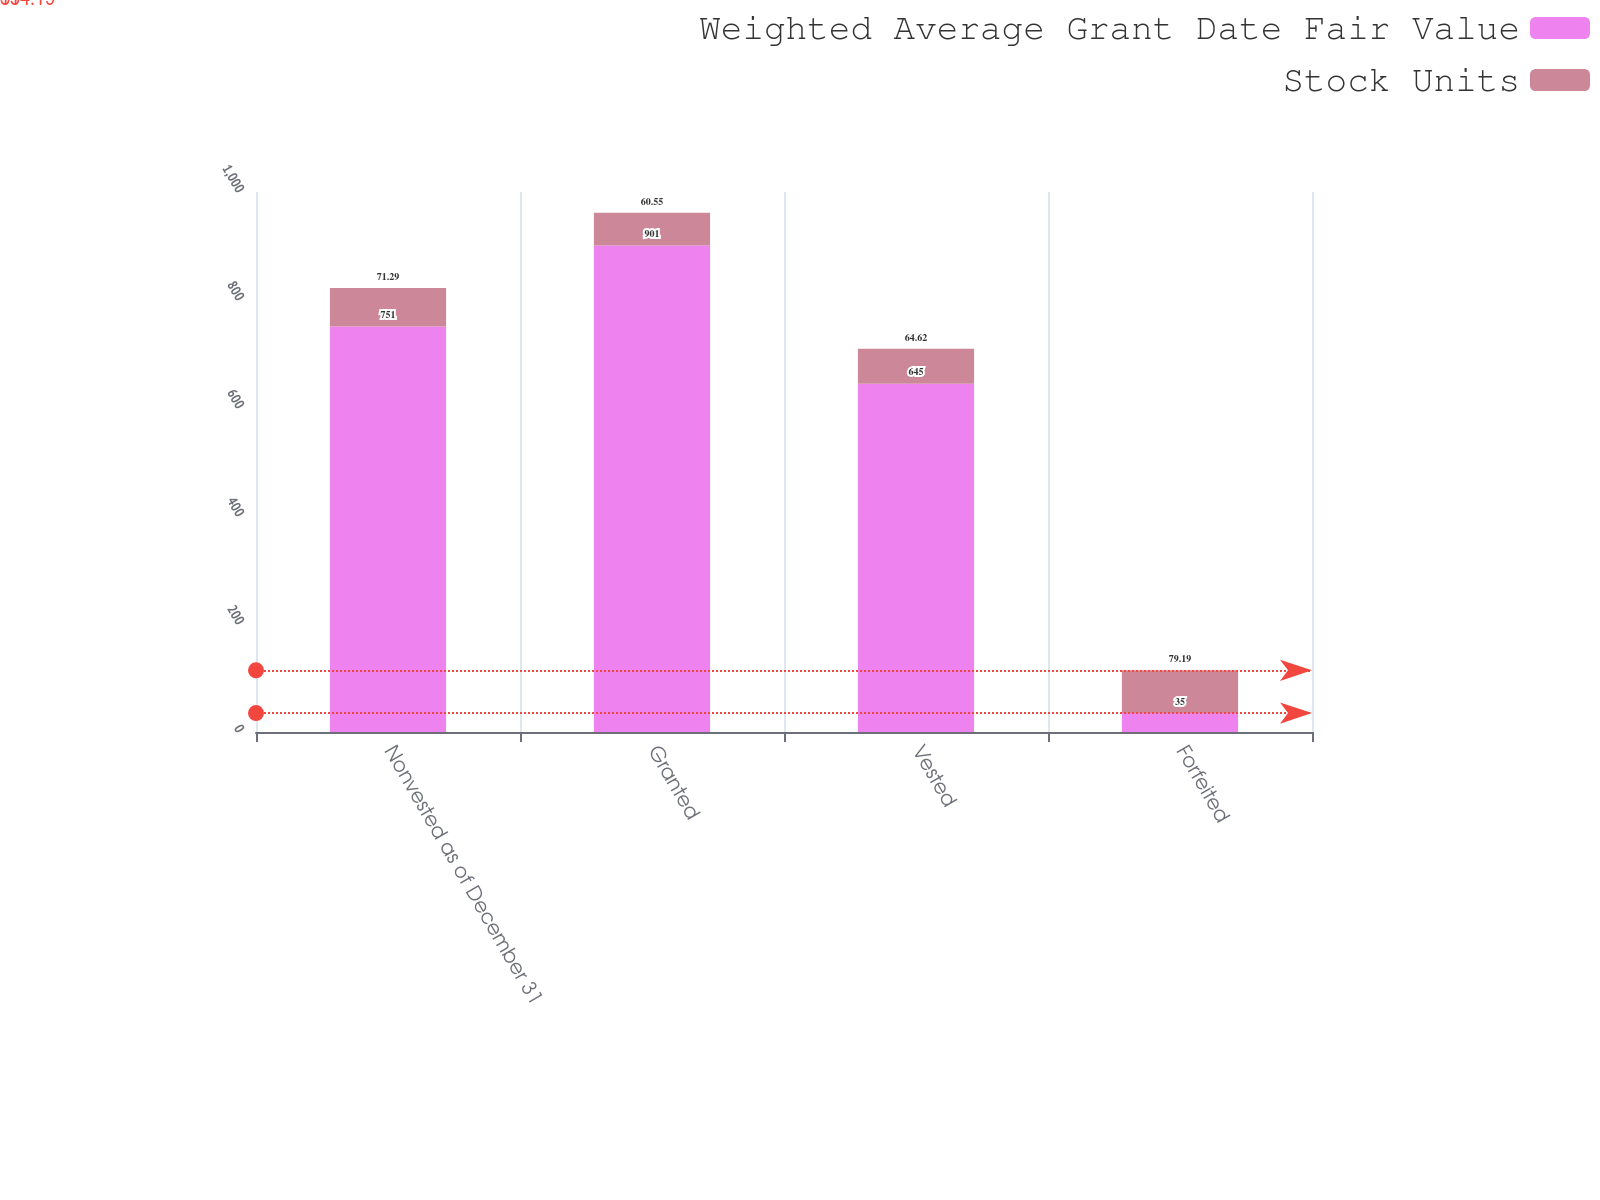Convert chart to OTSL. <chart><loc_0><loc_0><loc_500><loc_500><stacked_bar_chart><ecel><fcel>Nonvested as of December 31<fcel>Granted<fcel>Vested<fcel>Forfeited<nl><fcel>Weighted Average Grant Date Fair Value<fcel>751<fcel>901<fcel>645<fcel>35<nl><fcel>Stock Units<fcel>71.29<fcel>60.55<fcel>64.62<fcel>79.19<nl></chart> 